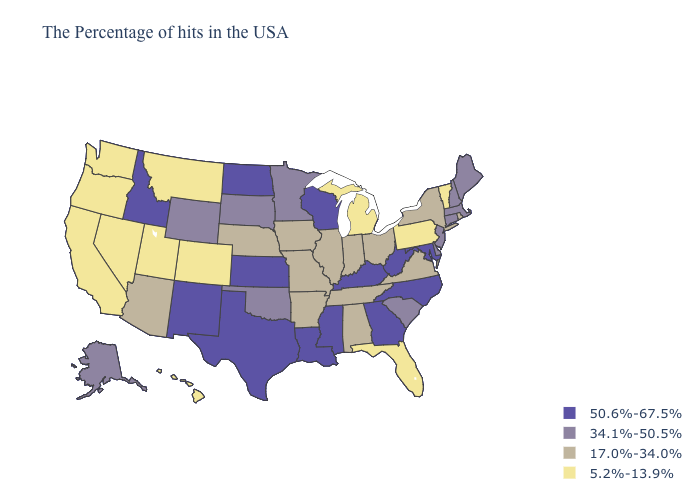Name the states that have a value in the range 17.0%-34.0%?
Give a very brief answer. Rhode Island, New York, Virginia, Ohio, Indiana, Alabama, Tennessee, Illinois, Missouri, Arkansas, Iowa, Nebraska, Arizona. Which states have the highest value in the USA?
Give a very brief answer. Maryland, North Carolina, West Virginia, Georgia, Kentucky, Wisconsin, Mississippi, Louisiana, Kansas, Texas, North Dakota, New Mexico, Idaho. What is the value of Tennessee?
Keep it brief. 17.0%-34.0%. What is the highest value in the South ?
Keep it brief. 50.6%-67.5%. Among the states that border California , which have the lowest value?
Be succinct. Nevada, Oregon. Is the legend a continuous bar?
Quick response, please. No. What is the value of Wisconsin?
Quick response, please. 50.6%-67.5%. Name the states that have a value in the range 5.2%-13.9%?
Short answer required. Vermont, Pennsylvania, Florida, Michigan, Colorado, Utah, Montana, Nevada, California, Washington, Oregon, Hawaii. Does Nebraska have the lowest value in the MidWest?
Keep it brief. No. Among the states that border Missouri , which have the lowest value?
Concise answer only. Tennessee, Illinois, Arkansas, Iowa, Nebraska. Does Louisiana have the highest value in the South?
Quick response, please. Yes. What is the value of Kansas?
Give a very brief answer. 50.6%-67.5%. How many symbols are there in the legend?
Write a very short answer. 4. Name the states that have a value in the range 5.2%-13.9%?
Write a very short answer. Vermont, Pennsylvania, Florida, Michigan, Colorado, Utah, Montana, Nevada, California, Washington, Oregon, Hawaii. Does Michigan have the highest value in the USA?
Quick response, please. No. 